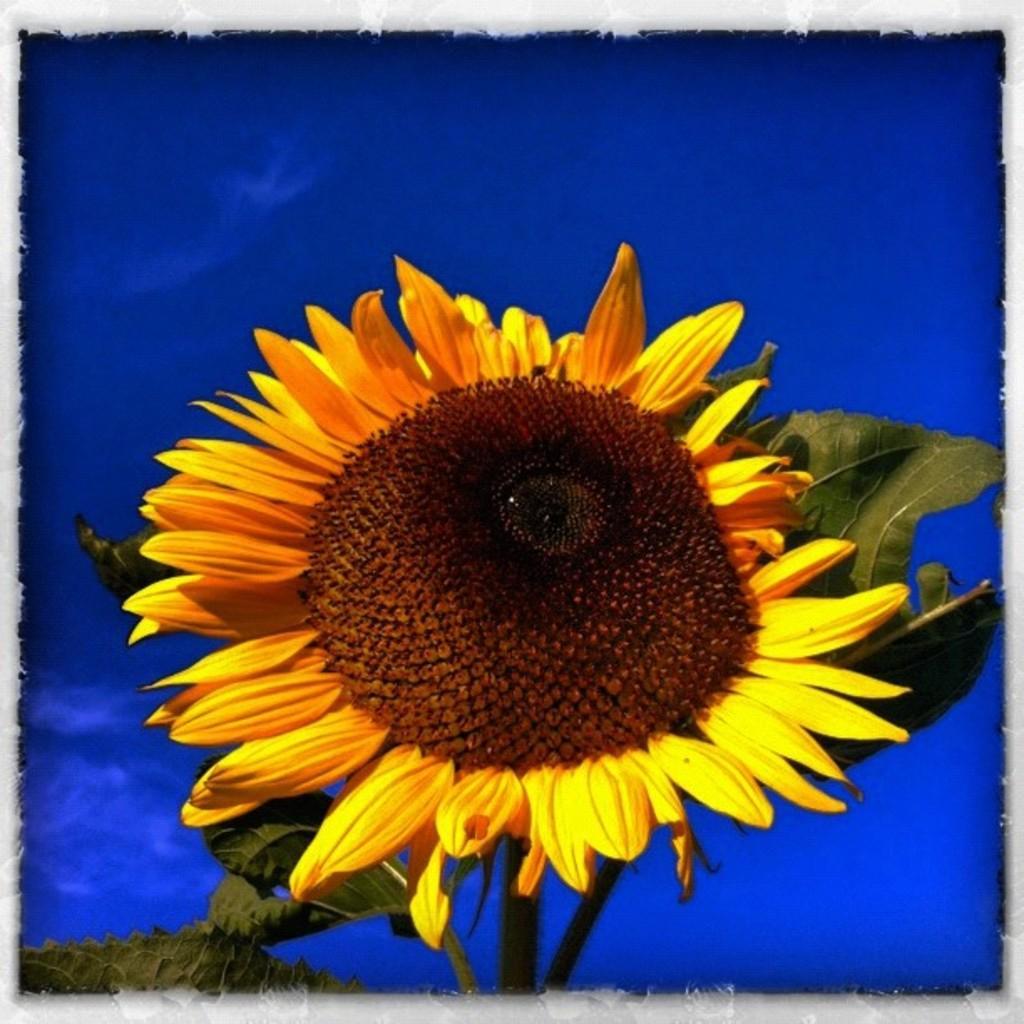Can you describe this image briefly? This image is an edited image. This image is taken outdoors. In the middle of the image there is a plant with a sunflower. The background is blue in color. 